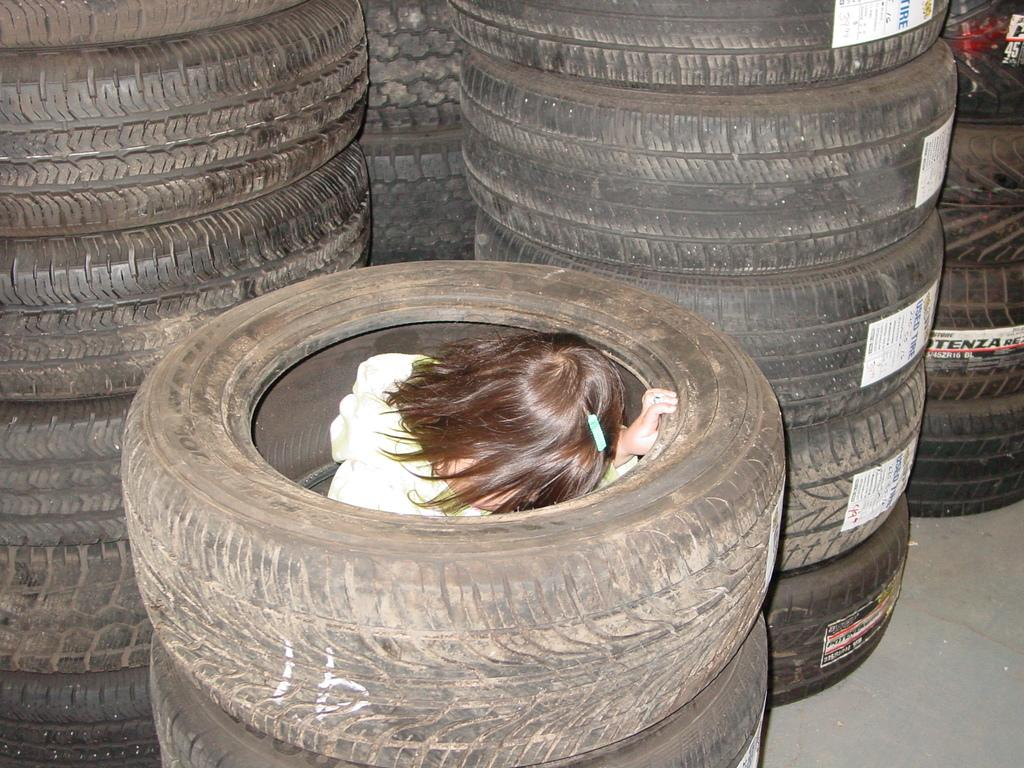What objects can be seen in the image? There are tires in the image. What additional details can be observed on the tires? There are information stickers on the tires. Who is present in the image? There is a girl in the image. Can you describe the girl's appearance? The girl has brown-colored short hair and is wearing a hair clip. What type of lace can be seen on the girl's shoes in the image? There is no mention of shoes or lace in the image; the girl is described as having brown-colored short hair and wearing a hair clip. 